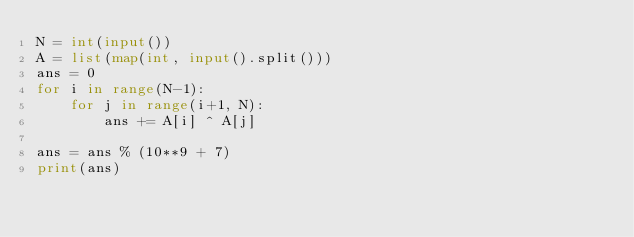<code> <loc_0><loc_0><loc_500><loc_500><_Python_>N = int(input())
A = list(map(int, input().split()))
ans = 0
for i in range(N-1):
    for j in range(i+1, N):
        ans += A[i] ^ A[j]

ans = ans % (10**9 + 7)
print(ans)
</code> 